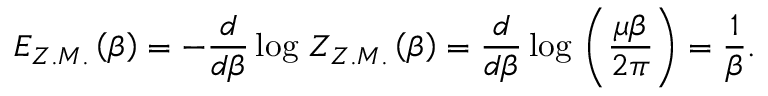Convert formula to latex. <formula><loc_0><loc_0><loc_500><loc_500>E _ { Z . M . } \left ( \beta \right ) = - \frac { d } { d \beta } \log \, Z _ { Z . M . } \left ( \beta \right ) = \frac { d } { d \beta } \log \, \left ( \frac { \mu \beta } { 2 \pi } \right ) = \frac { 1 } { \beta } .</formula> 